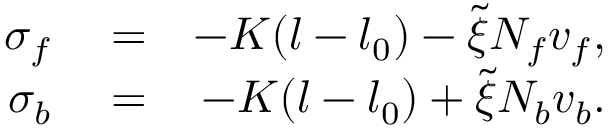Convert formula to latex. <formula><loc_0><loc_0><loc_500><loc_500>\begin{array} { r l r } { \sigma _ { f } } & = } & { - K ( l - l _ { 0 } ) - \tilde { \xi } N _ { f } v _ { f } , } \\ { \sigma _ { b } } & = } & { - K ( l - l _ { 0 } ) + \tilde { \xi } N _ { b } v _ { b } . } \end{array}</formula> 